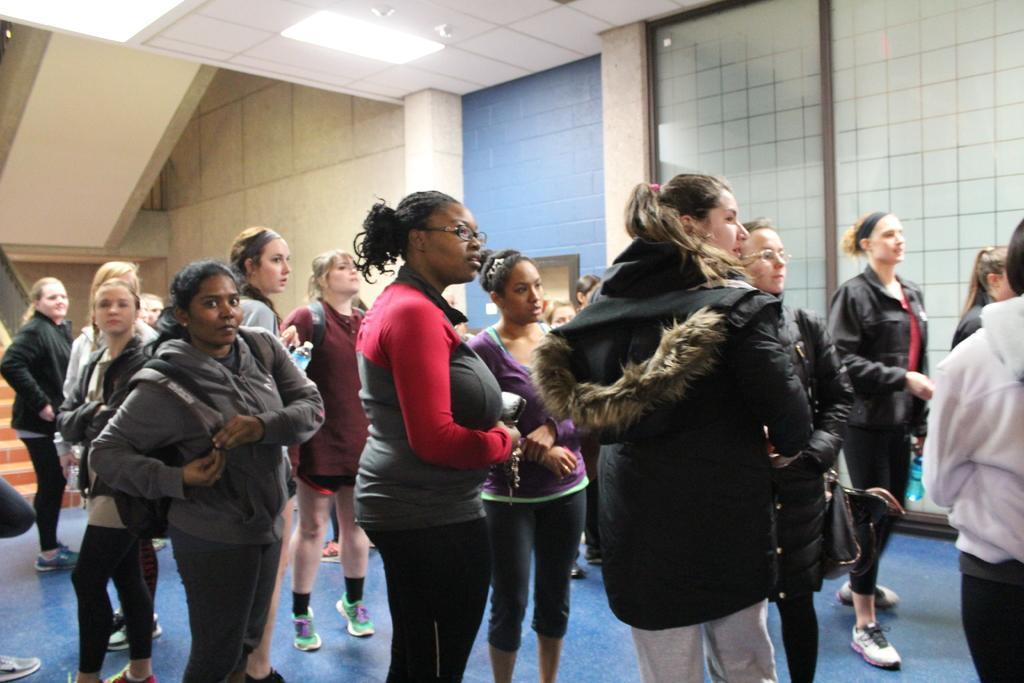How would you summarize this image in a sentence or two? This picture describes about group of people, in this we can find few women, in the background we can see a light and walls. 